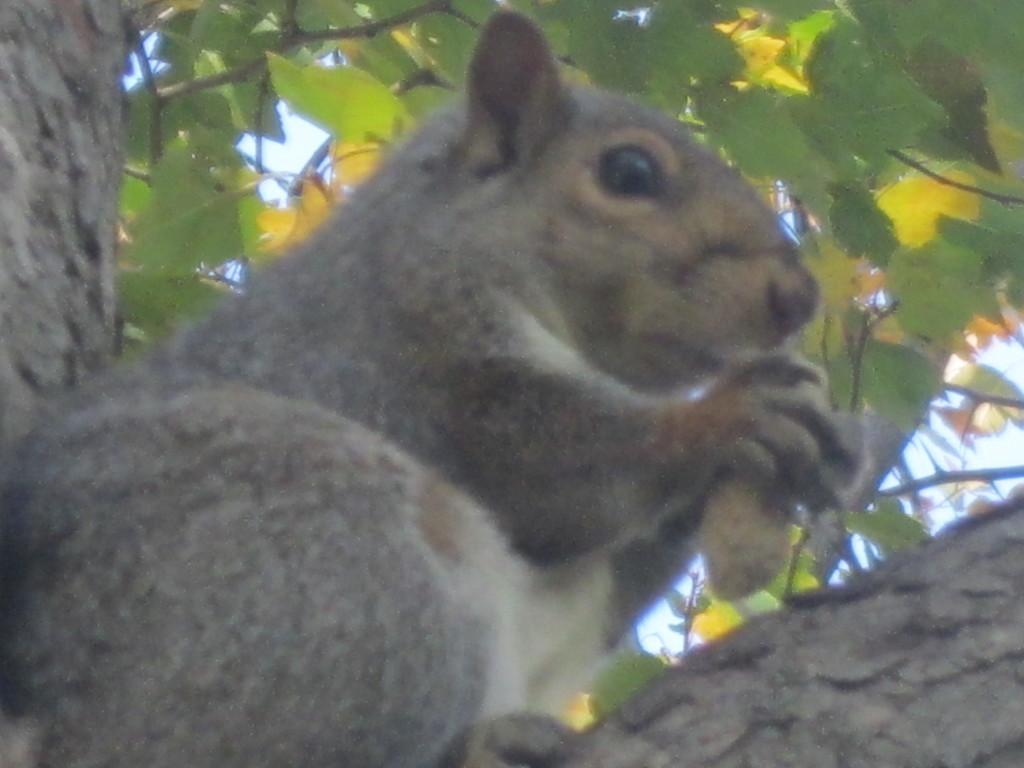What animal is present in the image? There is a squirrel in the image. What is the squirrel doing in the image? The squirrel is sitting and holding an object. What can be seen above the squirrel in the image? There are leaves above the squirrel in the image. What type of hook can be seen in the image? There is no hook present in the image. What railway is visible in the image? There is no railway present in the image. 